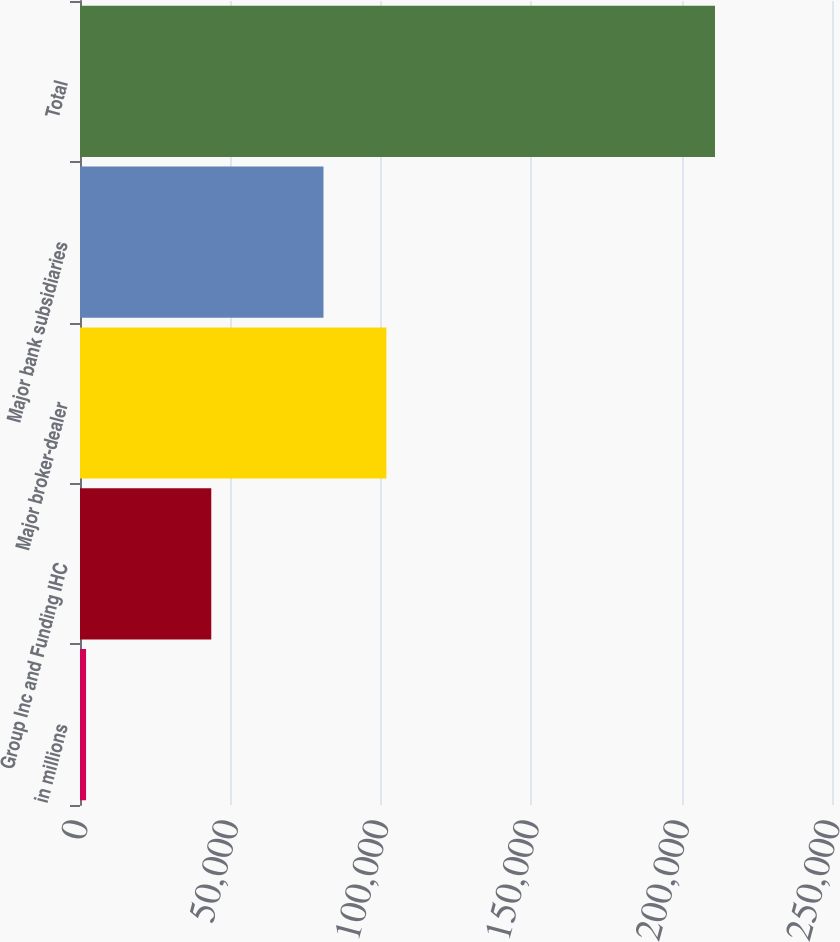Convert chart. <chart><loc_0><loc_0><loc_500><loc_500><bar_chart><fcel>in millions<fcel>Group Inc and Funding IHC<fcel>Major broker-dealer<fcel>Major bank subsidiaries<fcel>Total<nl><fcel>2016<fcel>43638<fcel>101855<fcel>80946<fcel>211103<nl></chart> 